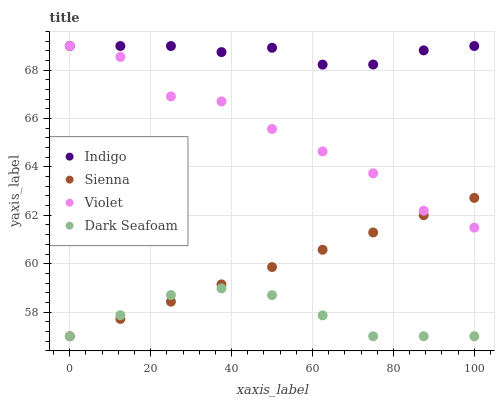Does Dark Seafoam have the minimum area under the curve?
Answer yes or no. Yes. Does Indigo have the maximum area under the curve?
Answer yes or no. Yes. Does Indigo have the minimum area under the curve?
Answer yes or no. No. Does Dark Seafoam have the maximum area under the curve?
Answer yes or no. No. Is Sienna the smoothest?
Answer yes or no. Yes. Is Violet the roughest?
Answer yes or no. Yes. Is Dark Seafoam the smoothest?
Answer yes or no. No. Is Dark Seafoam the roughest?
Answer yes or no. No. Does Sienna have the lowest value?
Answer yes or no. Yes. Does Indigo have the lowest value?
Answer yes or no. No. Does Violet have the highest value?
Answer yes or no. Yes. Does Dark Seafoam have the highest value?
Answer yes or no. No. Is Sienna less than Indigo?
Answer yes or no. Yes. Is Violet greater than Dark Seafoam?
Answer yes or no. Yes. Does Dark Seafoam intersect Sienna?
Answer yes or no. Yes. Is Dark Seafoam less than Sienna?
Answer yes or no. No. Is Dark Seafoam greater than Sienna?
Answer yes or no. No. Does Sienna intersect Indigo?
Answer yes or no. No. 